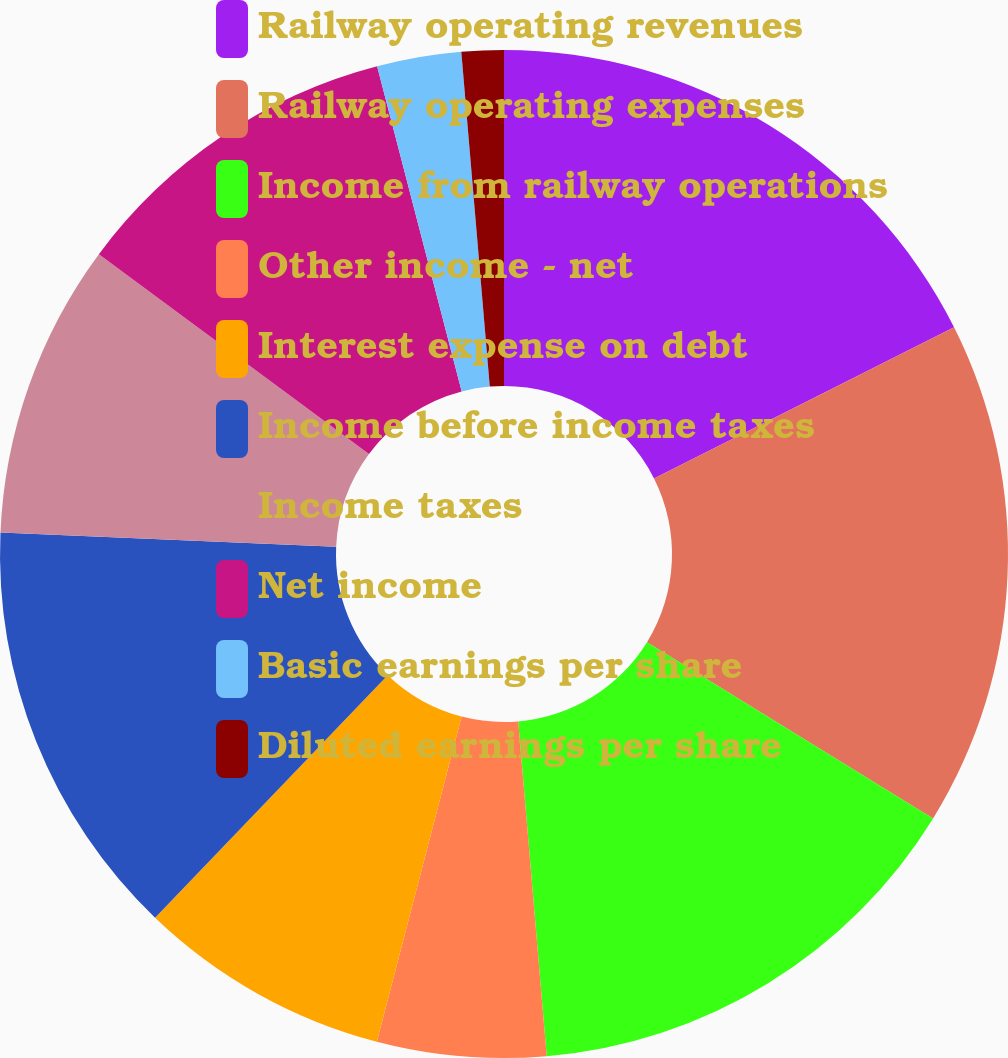Convert chart. <chart><loc_0><loc_0><loc_500><loc_500><pie_chart><fcel>Railway operating revenues<fcel>Railway operating expenses<fcel>Income from railway operations<fcel>Other income - net<fcel>Interest expense on debt<fcel>Income before income taxes<fcel>Income taxes<fcel>Net income<fcel>Basic earnings per share<fcel>Diluted earnings per share<nl><fcel>17.57%<fcel>16.22%<fcel>14.86%<fcel>5.41%<fcel>8.11%<fcel>13.51%<fcel>9.46%<fcel>10.81%<fcel>2.7%<fcel>1.35%<nl></chart> 